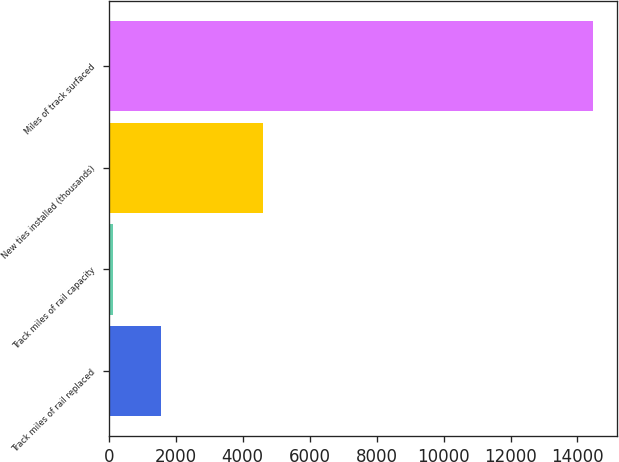<chart> <loc_0><loc_0><loc_500><loc_500><bar_chart><fcel>Track miles of rail replaced<fcel>Track miles of rail capacity<fcel>New ties installed (thousands)<fcel>Miles of track surfaced<nl><fcel>1551.6<fcel>118<fcel>4599<fcel>14454<nl></chart> 